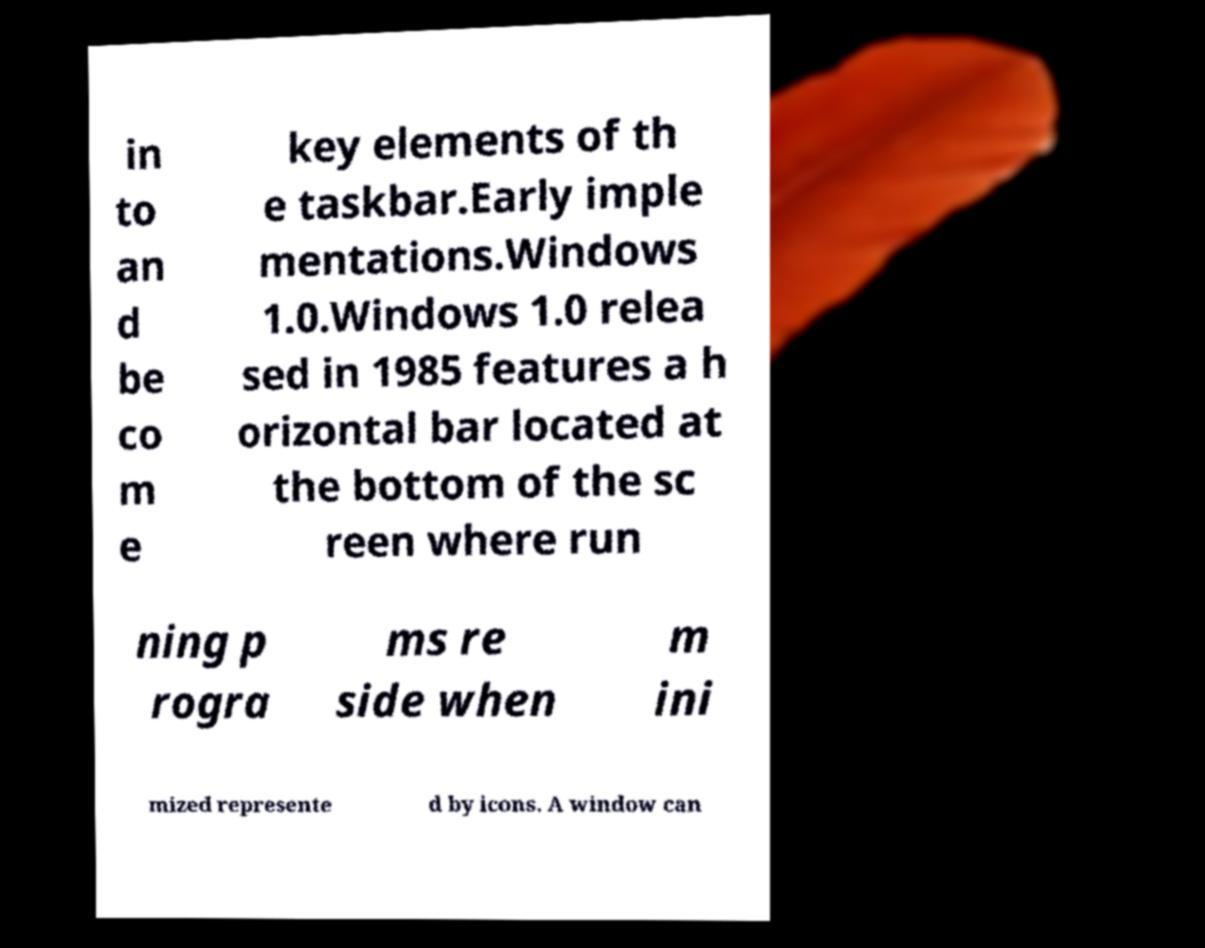Please read and relay the text visible in this image. What does it say? in to an d be co m e key elements of th e taskbar.Early imple mentations.Windows 1.0.Windows 1.0 relea sed in 1985 features a h orizontal bar located at the bottom of the sc reen where run ning p rogra ms re side when m ini mized represente d by icons. A window can 